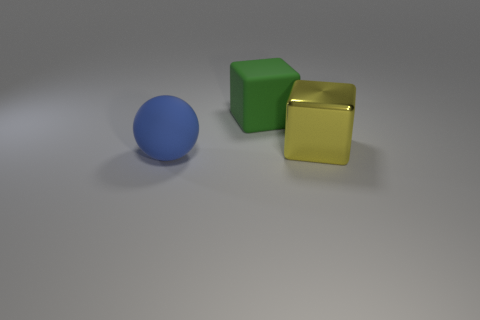What is the shape of the big thing that is on the right side of the large matte ball and left of the yellow thing? cube 